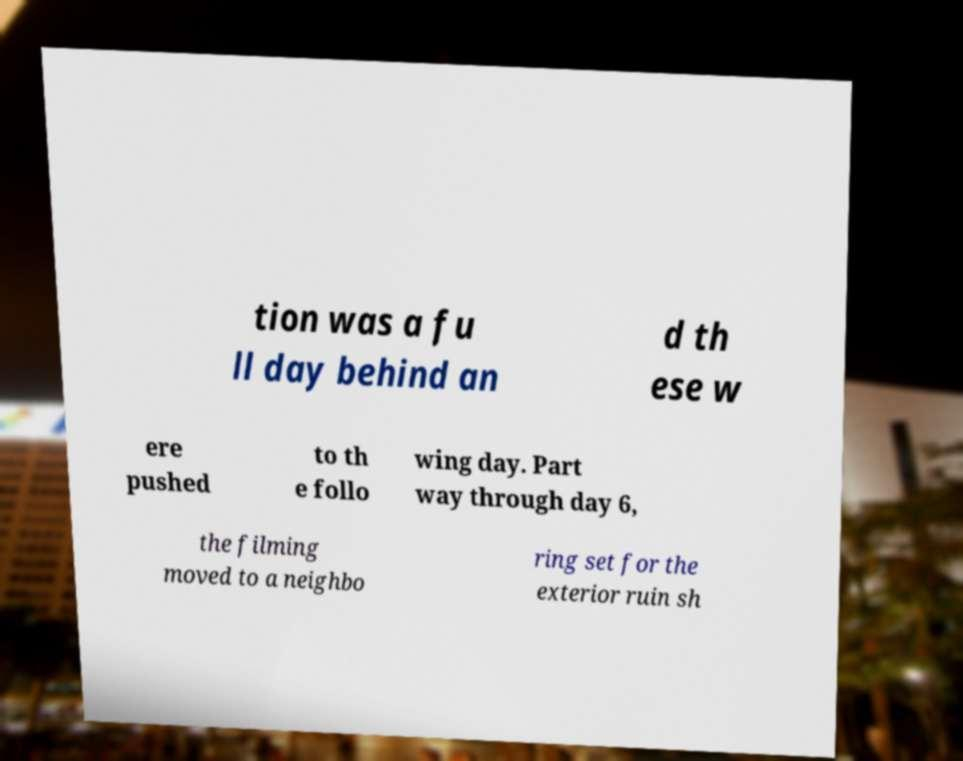Please identify and transcribe the text found in this image. tion was a fu ll day behind an d th ese w ere pushed to th e follo wing day. Part way through day 6, the filming moved to a neighbo ring set for the exterior ruin sh 